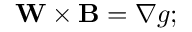<formula> <loc_0><loc_0><loc_500><loc_500>W \times \mathbf B = \nabla g ;</formula> 